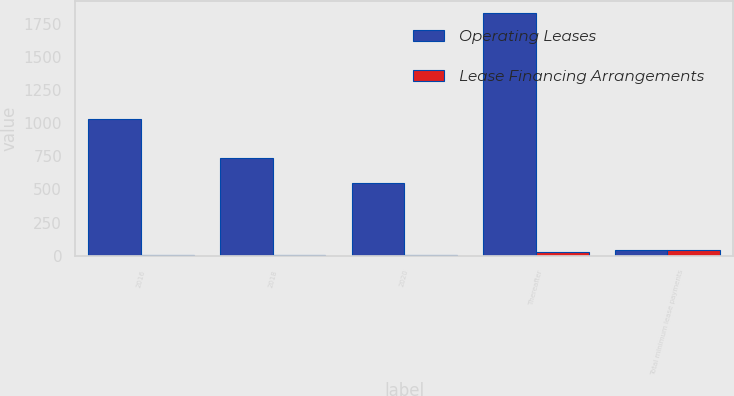<chart> <loc_0><loc_0><loc_500><loc_500><stacked_bar_chart><ecel><fcel>2016<fcel>2018<fcel>2020<fcel>Thereafter<fcel>Total minimum lease payments<nl><fcel>Operating Leases<fcel>1032.4<fcel>739.8<fcel>548.9<fcel>1831.9<fcel>47.1<nl><fcel>Lease Financing Arrangements<fcel>3.2<fcel>3.2<fcel>3.2<fcel>31.1<fcel>47.1<nl></chart> 